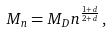<formula> <loc_0><loc_0><loc_500><loc_500>M _ { n } = M _ { D } n ^ { { \frac { 1 + d } { 2 + d } } } \, ,</formula> 